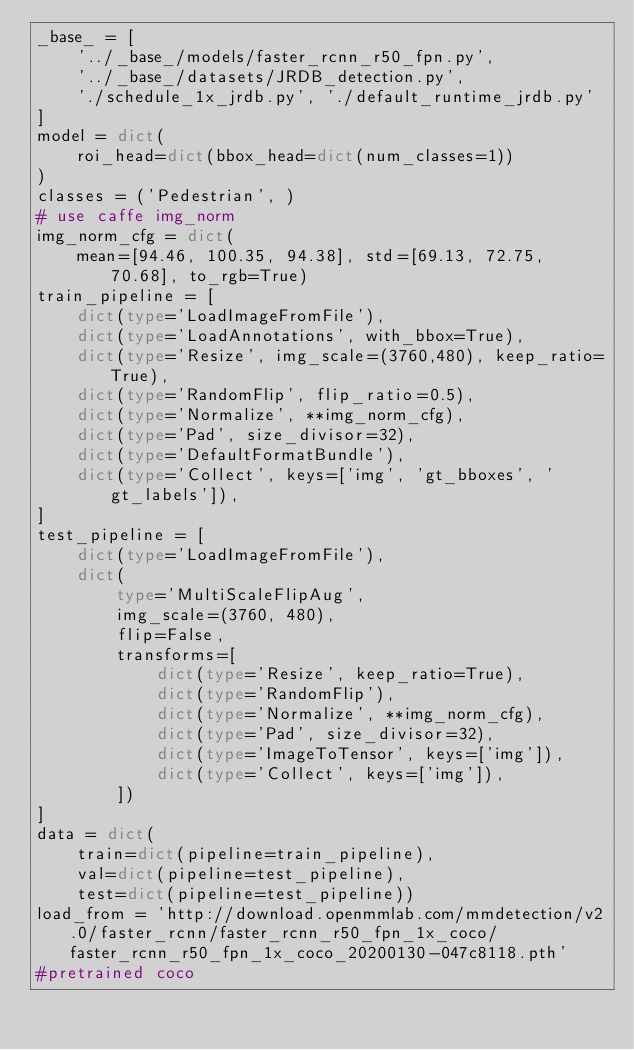<code> <loc_0><loc_0><loc_500><loc_500><_Python_>_base_ = [
    '../_base_/models/faster_rcnn_r50_fpn.py',
    '../_base_/datasets/JRDB_detection.py',
    './schedule_1x_jrdb.py', './default_runtime_jrdb.py'
]
model = dict(
    roi_head=dict(bbox_head=dict(num_classes=1))
)
classes = ('Pedestrian', )
# use caffe img_norm
img_norm_cfg = dict(
    mean=[94.46, 100.35, 94.38], std=[69.13, 72.75, 70.68], to_rgb=True)
train_pipeline = [
    dict(type='LoadImageFromFile'),
    dict(type='LoadAnnotations', with_bbox=True),
    dict(type='Resize', img_scale=(3760,480), keep_ratio=True),
    dict(type='RandomFlip', flip_ratio=0.5),
    dict(type='Normalize', **img_norm_cfg),
    dict(type='Pad', size_divisor=32),
    dict(type='DefaultFormatBundle'),
    dict(type='Collect', keys=['img', 'gt_bboxes', 'gt_labels']),
]
test_pipeline = [
    dict(type='LoadImageFromFile'),
    dict(
        type='MultiScaleFlipAug',
        img_scale=(3760, 480),
        flip=False,
        transforms=[
            dict(type='Resize', keep_ratio=True),
            dict(type='RandomFlip'),
            dict(type='Normalize', **img_norm_cfg),
            dict(type='Pad', size_divisor=32),
            dict(type='ImageToTensor', keys=['img']),
            dict(type='Collect', keys=['img']),
        ])
]
data = dict(
    train=dict(pipeline=train_pipeline),
    val=dict(pipeline=test_pipeline),
    test=dict(pipeline=test_pipeline))
load_from = 'http://download.openmmlab.com/mmdetection/v2.0/faster_rcnn/faster_rcnn_r50_fpn_1x_coco/faster_rcnn_r50_fpn_1x_coco_20200130-047c8118.pth'
#pretrained coco
</code> 